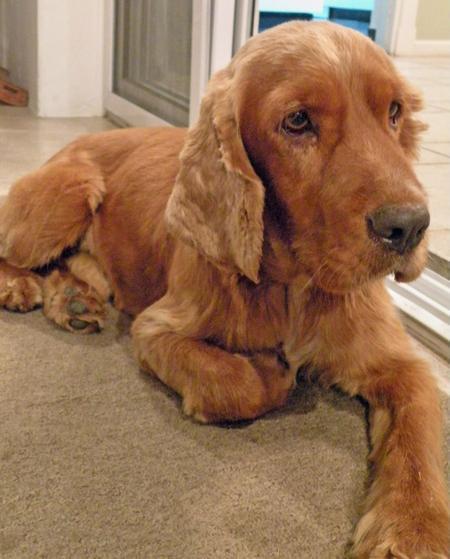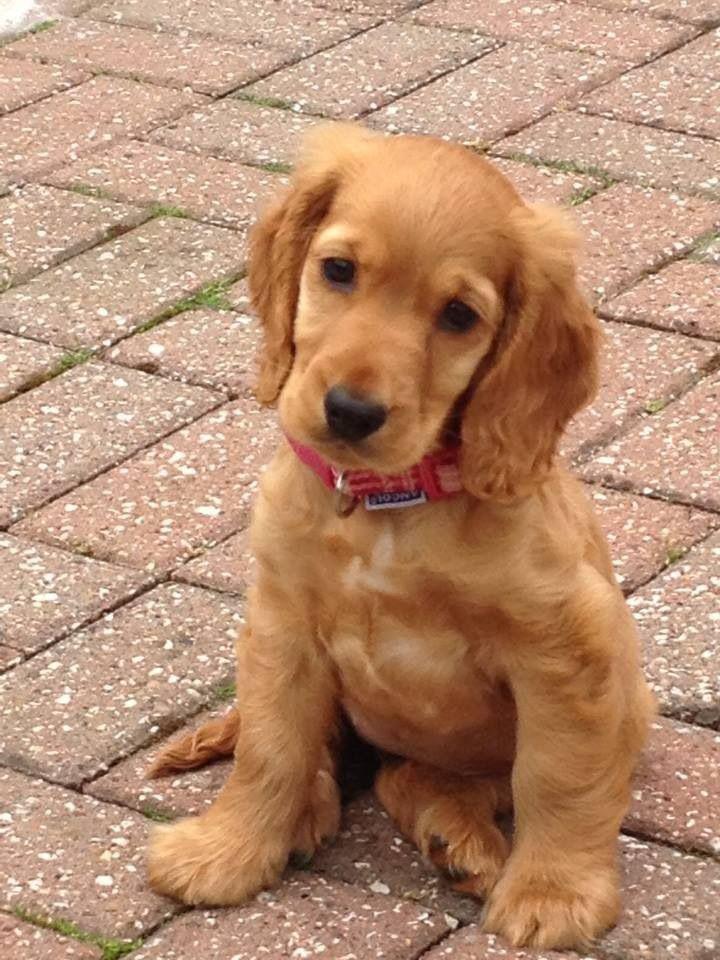The first image is the image on the left, the second image is the image on the right. Analyze the images presented: Is the assertion "A blue object hangs from the collar of the dog in one of the images." valid? Answer yes or no. No. 